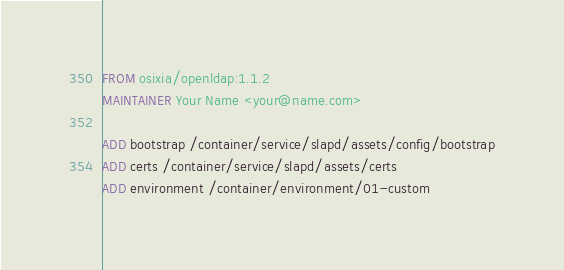Convert code to text. <code><loc_0><loc_0><loc_500><loc_500><_Dockerfile_>FROM osixia/openldap:1.1.2
MAINTAINER Your Name <your@name.com>

ADD bootstrap /container/service/slapd/assets/config/bootstrap
ADD certs /container/service/slapd/assets/certs
ADD environment /container/environment/01-custom
</code> 